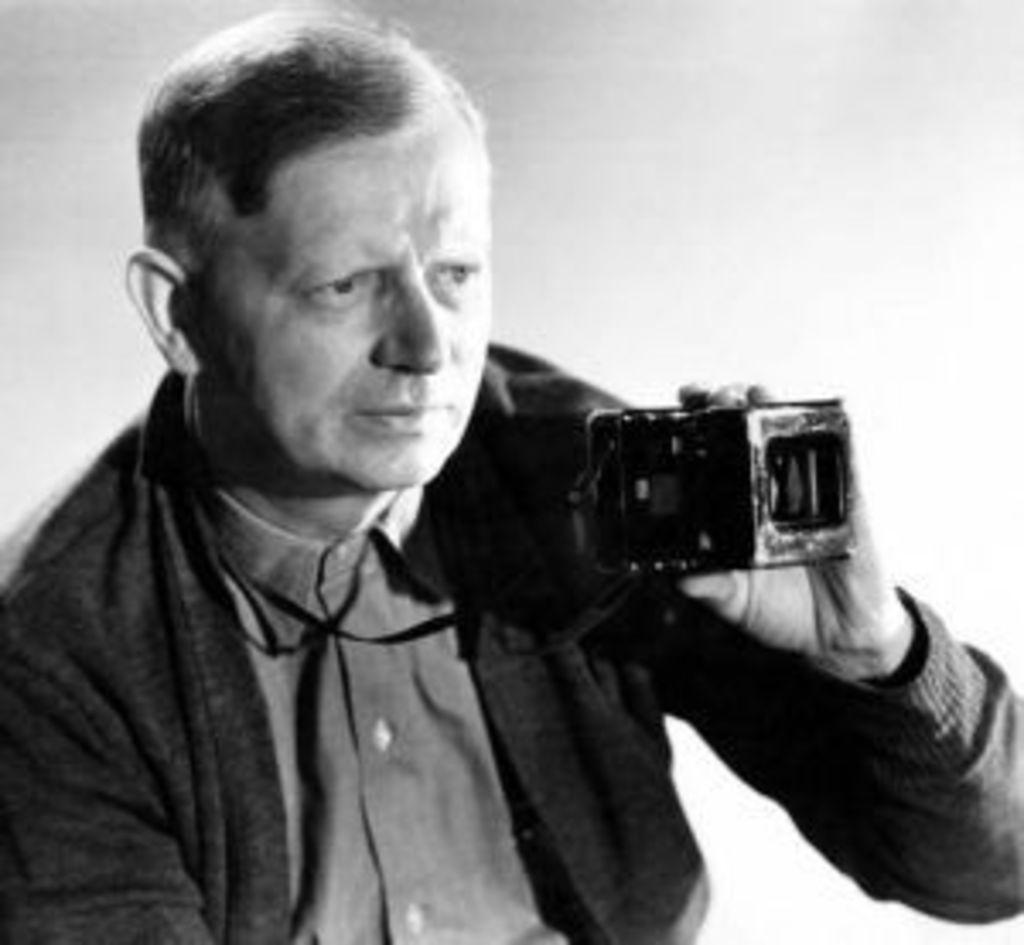What is the color scheme of the image? The picture is black and white. What is the person in the image wearing? The person is wearing a black jacket. What is the person holding in the image? The person is holding a camera. What type of spoon can be seen in the person's hand in the image? There is no spoon present in the image; the person is holding a camera. What rule is being enforced by the person in the image? There is no indication of any rule being enforced in the image; the person is simply holding a camera. 